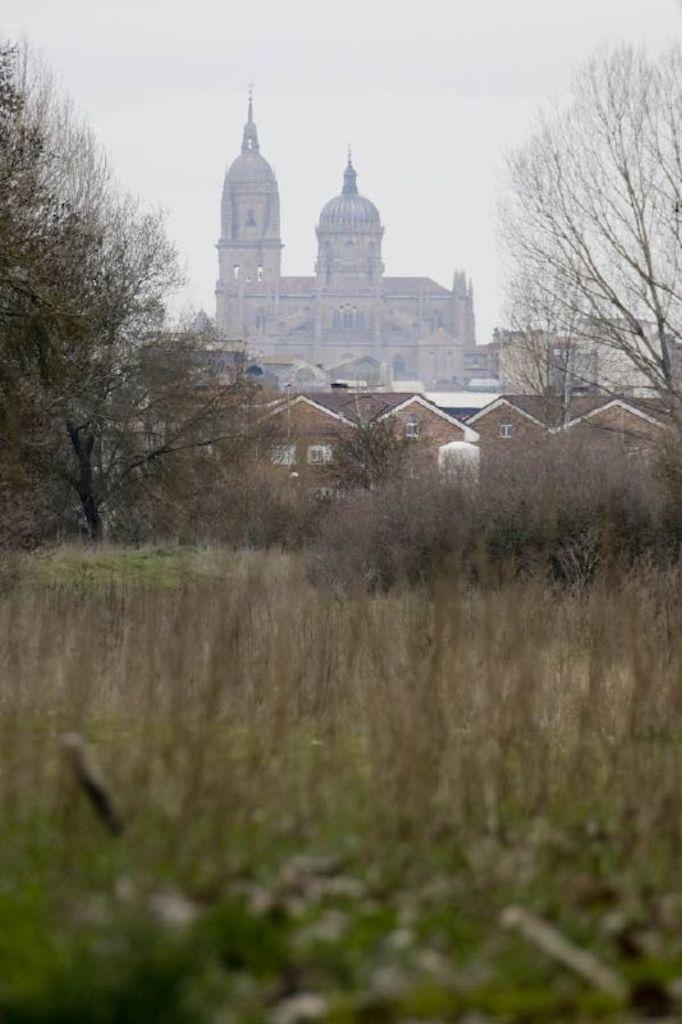Describe this image in one or two sentences. In this image we can see grass, trees, few buildings and sky in the background. 